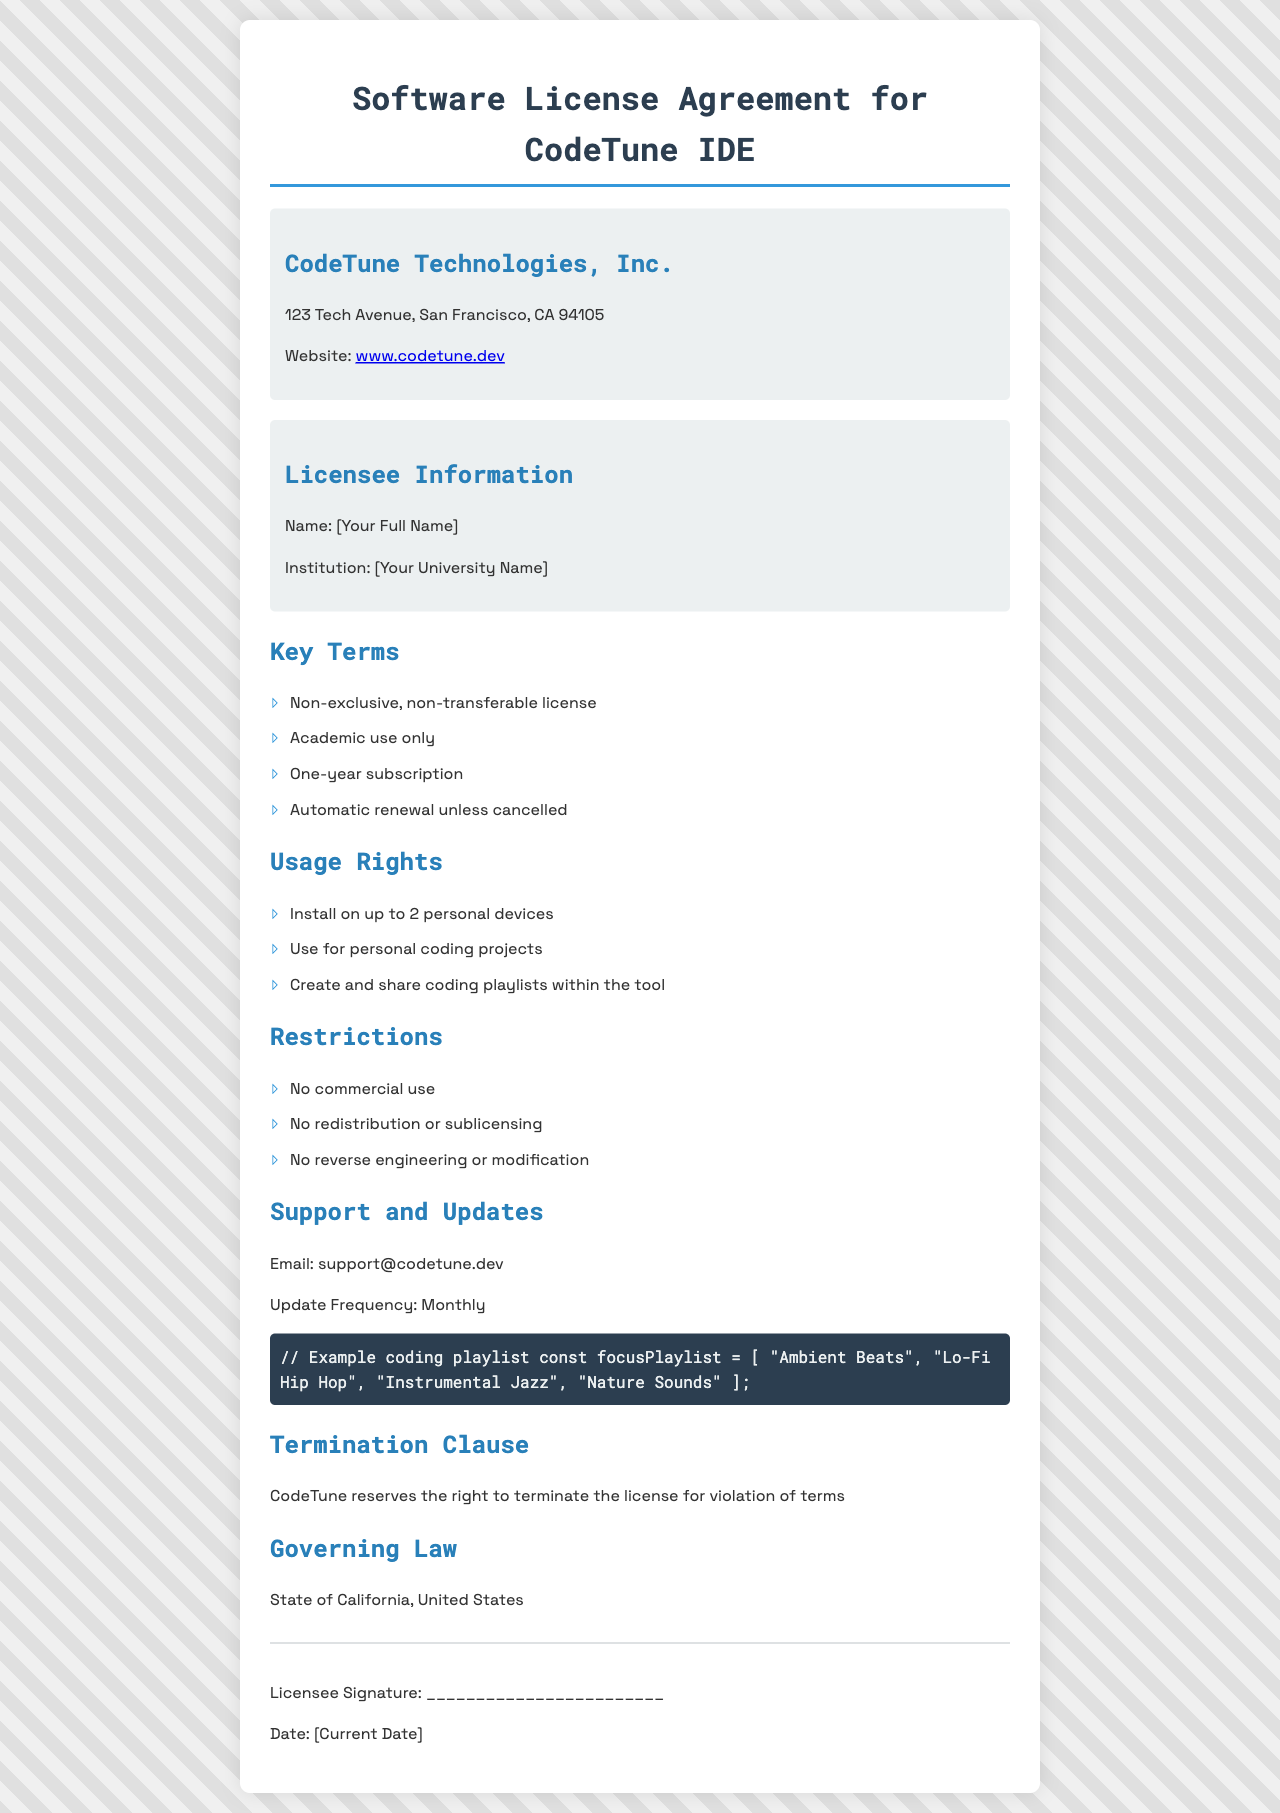What is the name of the company granting the license? The name of the company is listed at the top of the document under company information.
Answer: CodeTune Technologies, Inc What is the license type? The first key term in the document specifies the nature of the license provided to the user.
Answer: Non-exclusive, non-transferable license How many personal devices can the software be installed on? This information is in the "Usage Rights" section detailing installation rights.
Answer: Up to 2 personal devices What is the duration of the subscription? The duration of the subscription is mentioned in the "Key Terms" section.
Answer: One-year subscription Can the software be used for commercial purposes? The "Restrictions" section clearly outlines use limitations for the software.
Answer: No What is the email for support? The support email is listed in the "Support and Updates" section.
Answer: support@codetune.dev Which state governs this license agreement? This information is provided in the "Governing Law" section of the document.
Answer: California What is the update frequency for the software? This is mentioned in the "Support and Updates" section concerning how often updates are made available.
Answer: Monthly What is required from the licensee in case of termination? The termination clause outlines the consequences for violation of terms; this requires responsibility on the licensee's part.
Answer: Violation of terms 